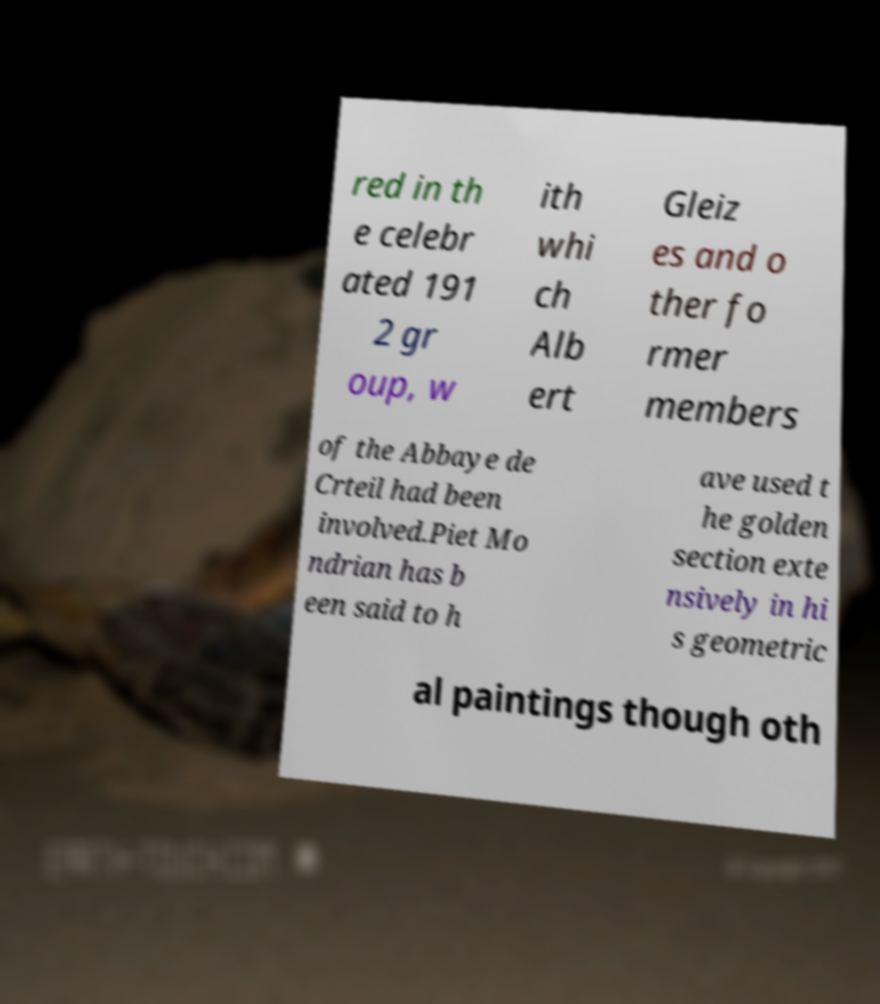Could you assist in decoding the text presented in this image and type it out clearly? red in th e celebr ated 191 2 gr oup, w ith whi ch Alb ert Gleiz es and o ther fo rmer members of the Abbaye de Crteil had been involved.Piet Mo ndrian has b een said to h ave used t he golden section exte nsively in hi s geometric al paintings though oth 